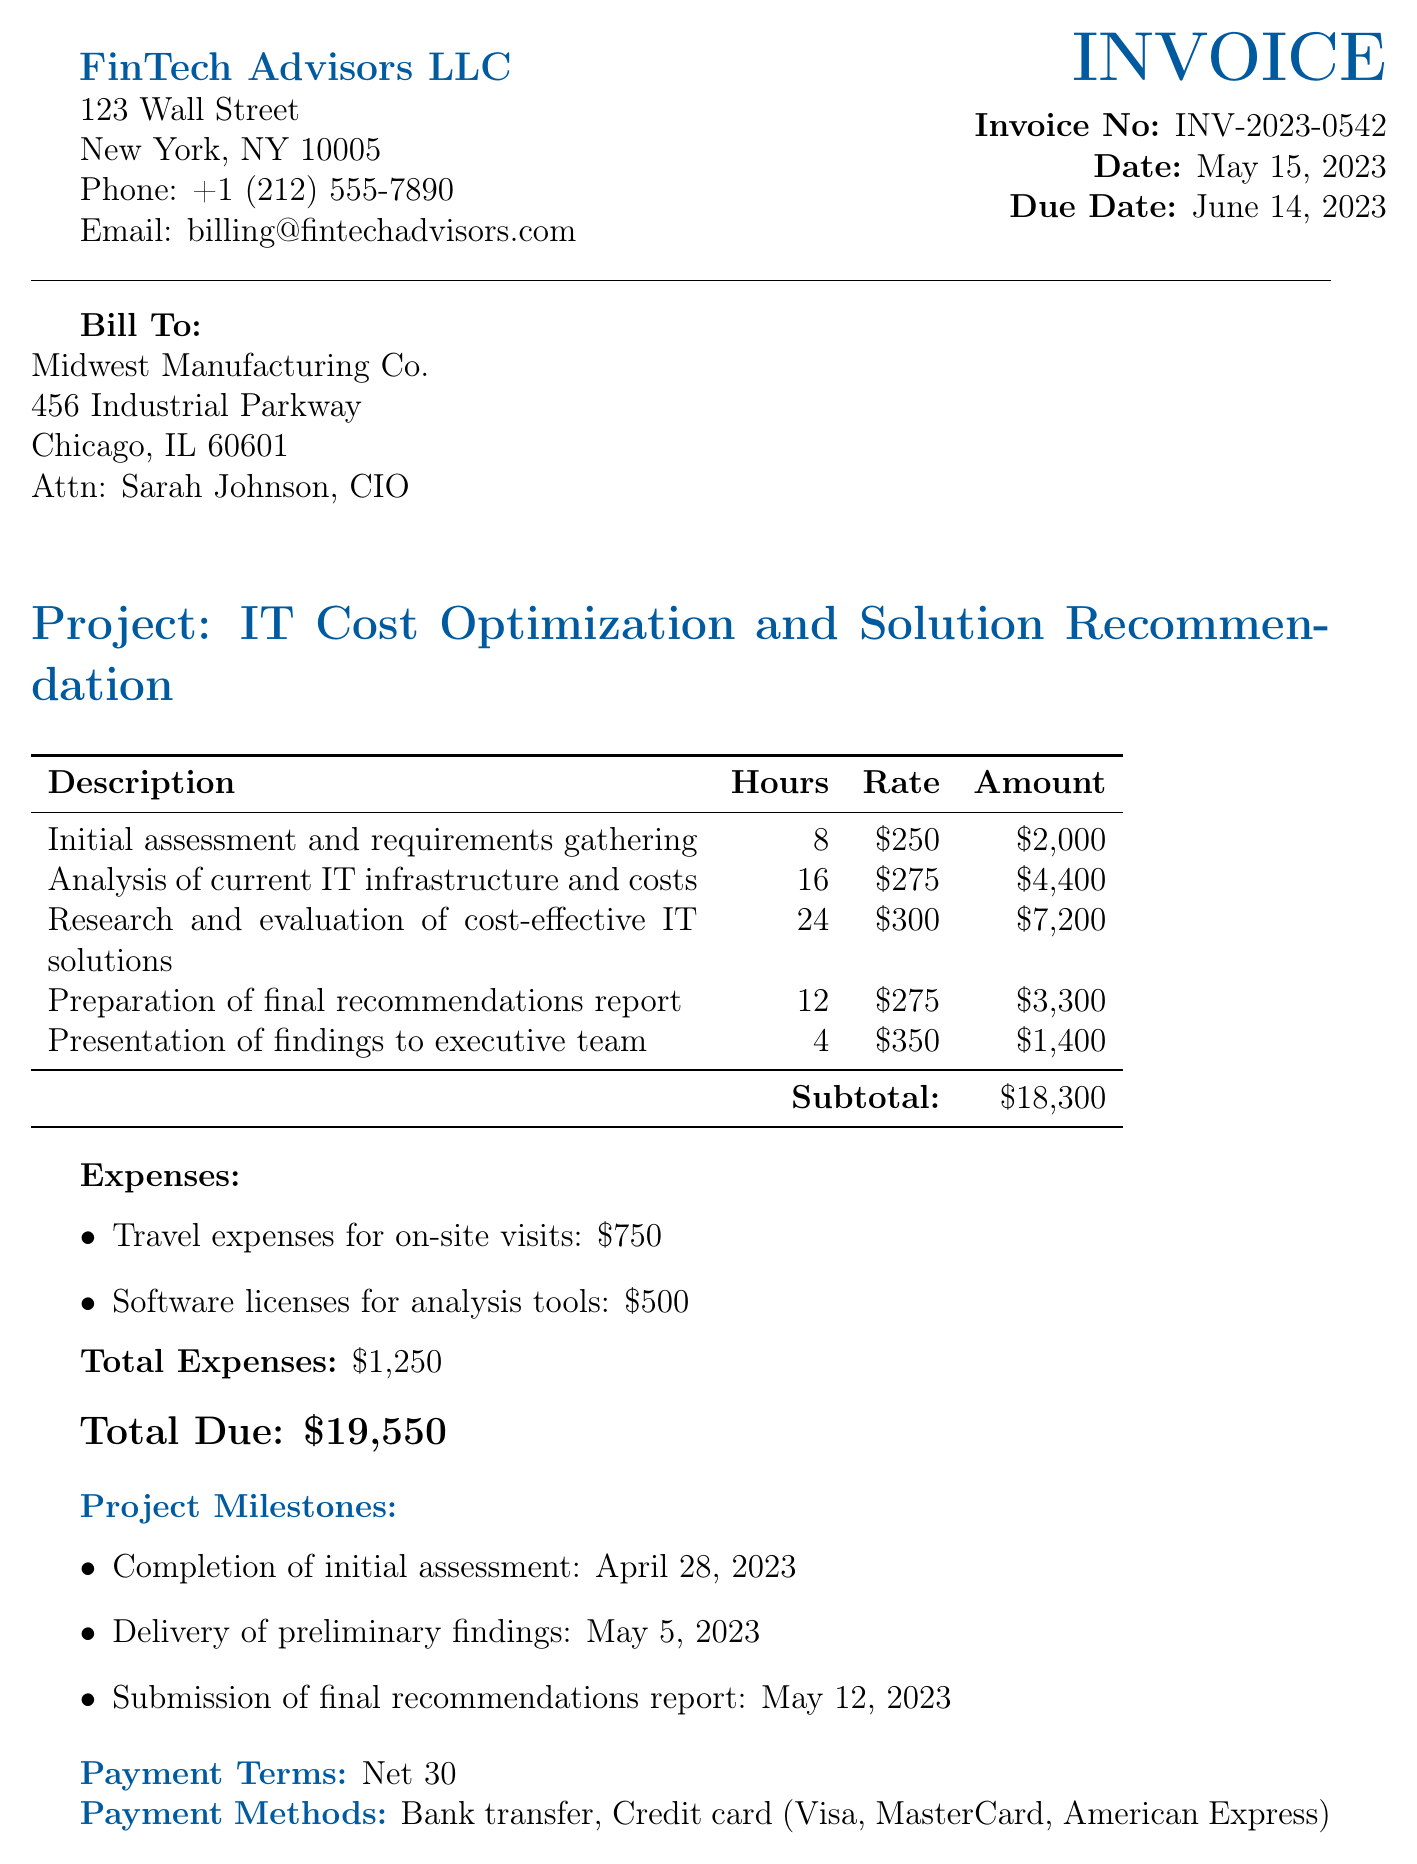What is the invoice number? The invoice number is displayed prominently in the document and is labeled as Invoice No.
Answer: INV-2023-0542 What is the due date for the invoice? The due date is mentioned in the document, indicating when payment is expected.
Answer: June 14, 2023 How many hours were spent on the analysis of current IT infrastructure? The document specifies the exact hours allocated for various tasks, including this one.
Answer: 16 What is the hourly rate for the preparation of the final recommendations report? The hourly rate for this specific task is listed in the table of services provided.
Answer: $275 What is the total amount charged for research and evaluation of cost-effective IT solutions? The amount is calculated based on hours worked and the hourly rate, and is clearly mentioned.
Answer: $7,200 What are the total expenses listed in the invoice? Total expenses are calculated and presented at the end of the expense section of the document.
Answer: $1,250 How many project milestones are mentioned in the invoice? The invoice lists specific milestones that correspond to key dates and achievements in the project.
Answer: 3 What payment terms are specified in the document? The document outlines specific payment terms that describe the timeframe for payment.
Answer: Net 30 What is the total amount due for the services rendered? The total due is presented at the end of the invoice, summarizing all costs including expenses.
Answer: $19,550 